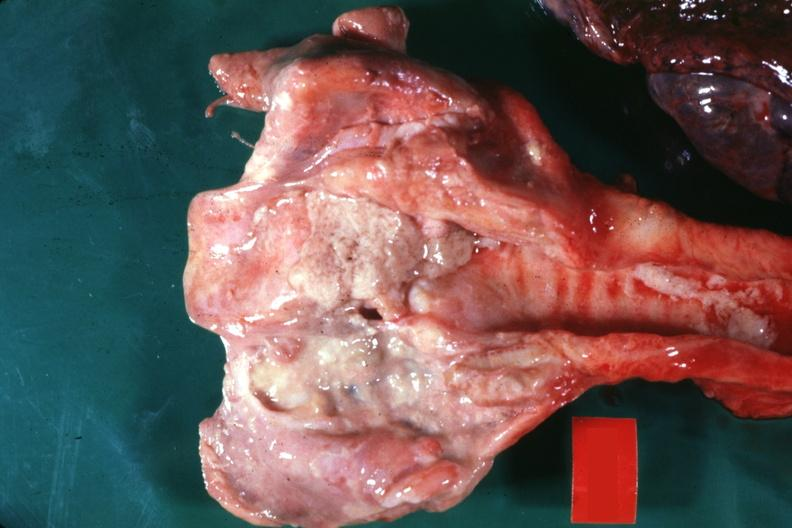does this image show large ulcers probably secondary to tube?
Answer the question using a single word or phrase. Yes 